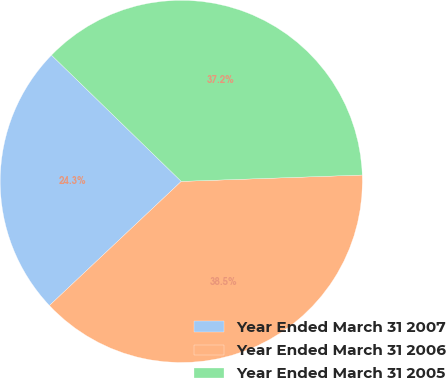Convert chart to OTSL. <chart><loc_0><loc_0><loc_500><loc_500><pie_chart><fcel>Year Ended March 31 2007<fcel>Year Ended March 31 2006<fcel>Year Ended March 31 2005<nl><fcel>24.3%<fcel>38.54%<fcel>37.16%<nl></chart> 